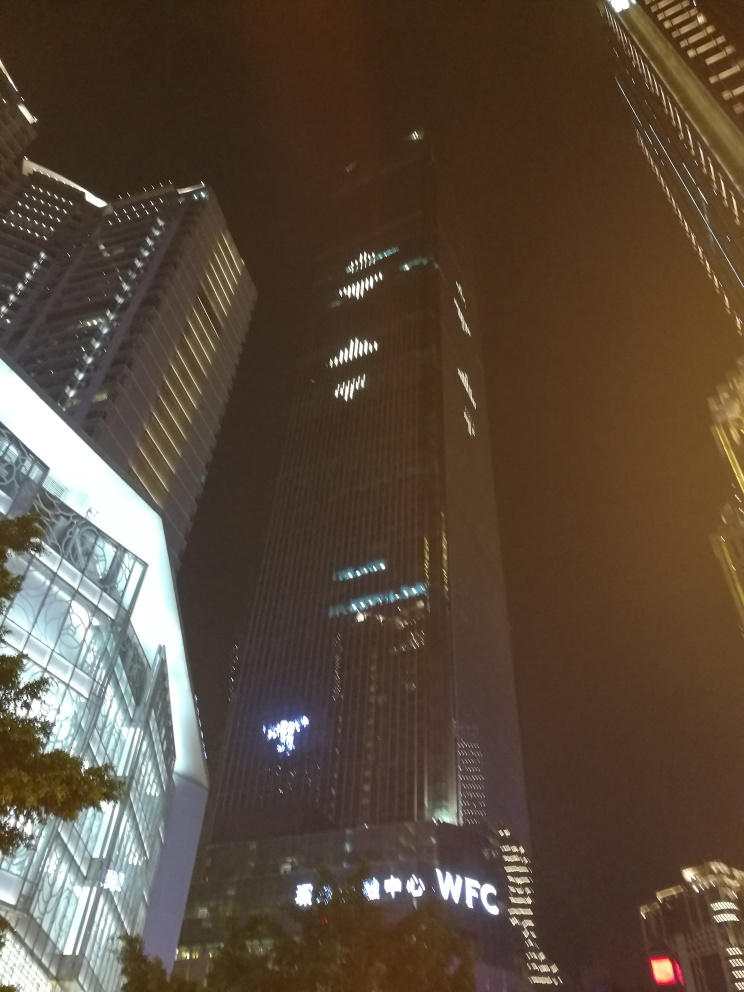What kind of buildings are shown in the image? The image features modern skyscrapers, likely part of a financial district given the prominent signage reading 'WFC,' which could hint at a World Financial Center or something similar. These high-rise buildings are characteristic of urban commercial areas and are typically used for offices, hotels, or mixed-use developments. 